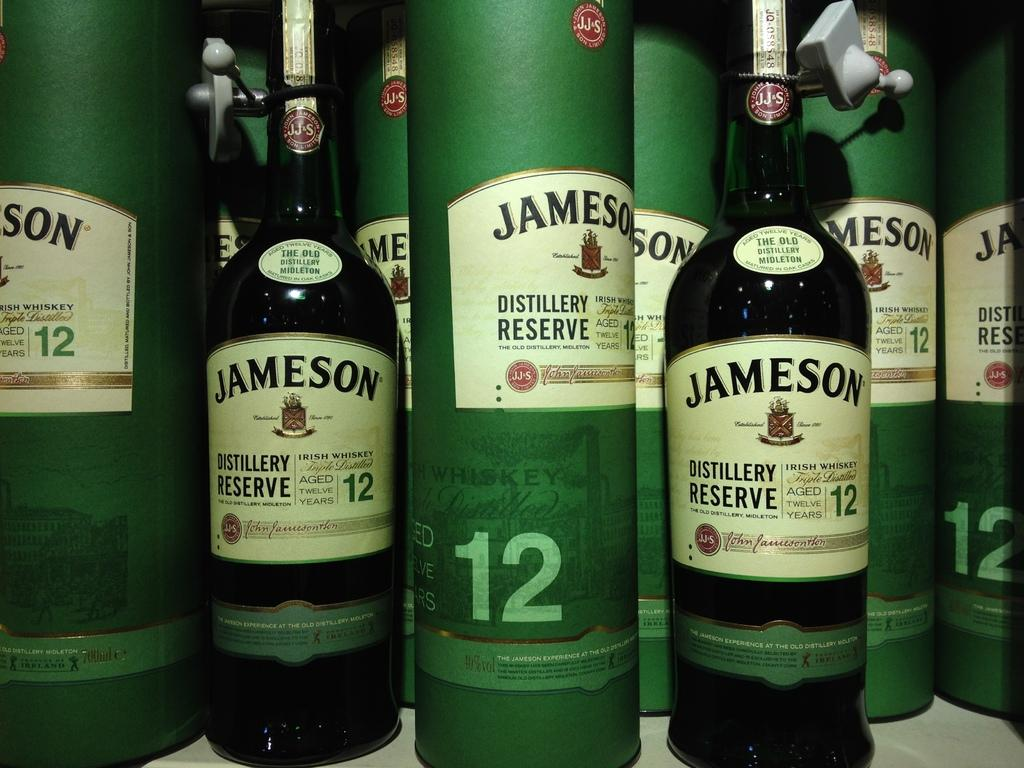<image>
Relay a brief, clear account of the picture shown. Many bottles of Jameson are showcased with the number 12 on the label. 